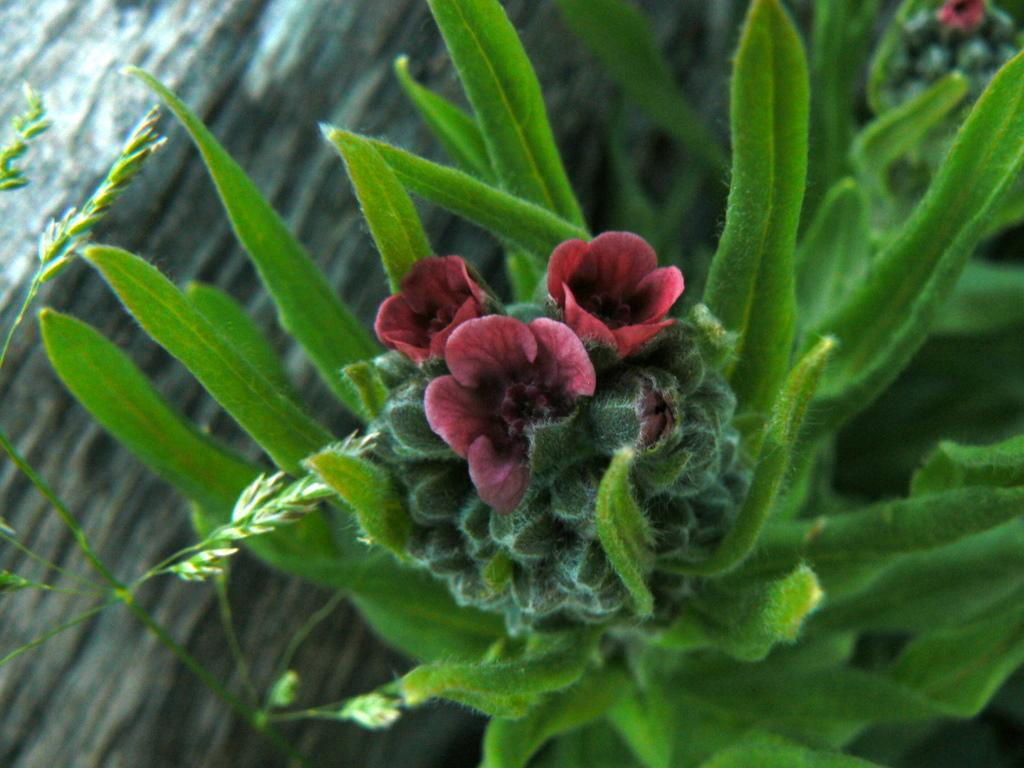What is the main subject in the center of the image? There is a plant in the center of the image. What can be seen on the plant? There are flowers on the plant. What can be observed in the background of the image? There are objects visible in the background of the image. What type of news is being discussed around the plant in the image? There is no indication of a news discussion or any people in the image, so it cannot be determined from the image. 